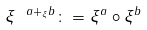Convert formula to latex. <formula><loc_0><loc_0><loc_500><loc_500>\xi ^ { \ a + _ { \xi } b } \colon = \xi ^ { a } \circ \xi ^ { b }</formula> 